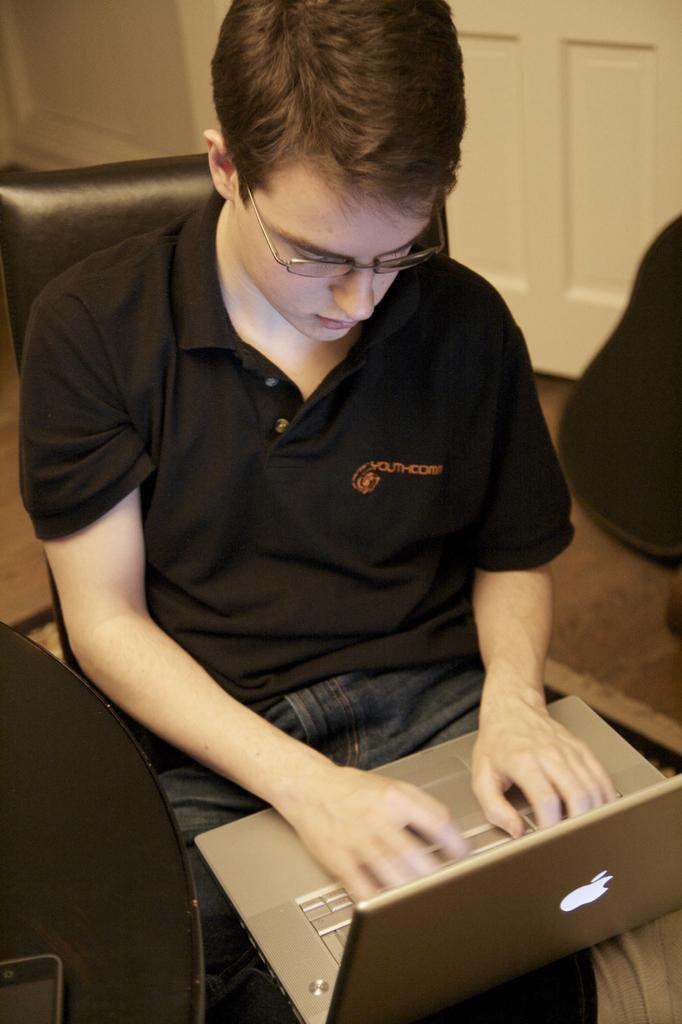Can you describe this image briefly? In this image, we can see a man sitting on a chair and using a laptop. In the background, we can see a door. 